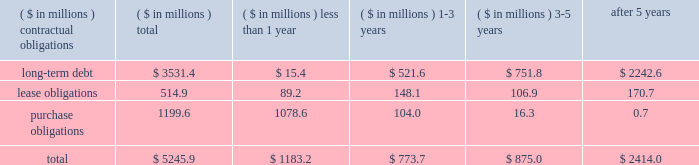The liabilities recognized as a result of consolidating these entities do not represent additional claims on the general assets of the company .
The creditors of these entities have claims only on the assets of the specific variable interest entities to which they have advanced credit .
Obligations and commitments as part of its ongoing operations , the company enters into arrangements that obligate the company to make future payments under contracts such as debt agreements , lease agreements , and unconditional purchase obligations ( i.e. , obligations to transfer funds in the future for fixed or minimum quantities of goods or services at fixed or minimum prices , such as 201ctake-or-pay 201d contracts ) .
The unconditional purchase obligation arrangements are entered into by the company in its normal course of business in order to ensure adequate levels of sourced product are available to the company .
Capital lease and debt obligations , which totaled $ 3.5 billion at may 25 , 2008 , are currently recognized as liabilities in the company 2019s consolidated balance sheet .
Operating lease obligations and unconditional purchase obligations , which totaled $ 1.7 billion at may 25 , 2008 , are not recognized as liabilities in the company 2019s consolidated balance sheet , in accordance with generally accepted accounting principles .
A summary of the company 2019s contractual obligations at the end of fiscal 2008 was as follows ( including obligations of discontinued operations ) : .
The purchase obligations noted in the table above do not reflect approximately $ 374 million of open purchase orders , some of which are not legally binding .
These purchase orders are settlable in the ordinary course of business in less than one year .
The company is also contractually obligated to pay interest on its long-term debt obligations .
The weighted average interest rate of the long-term debt obligations outstanding as of may 25 , 2008 was approximately 7.2% ( 7.2 % ) .
The company consolidates the assets and liabilities of certain entities from which it leases corporate aircraft .
These entities have been determined to be variable interest entities and the company has been determined to be the primary beneficiary of these entities .
The amounts reflected in contractual obligations of long-term debt , in the table above , include $ 54 million of liabilities of these variable interest entities to the creditors of such entities .
The long-term debt recognized as a result of consolidating these entities does not represent additional claims on the general assets of the company .
The creditors of these entities have claims only on the assets of the specific variable interest entities .
As of may 25 , 2008 , the company was obligated to make rental payments of $ 67 million to the variable interest entities , of which $ 7 million is due in less than one year , $ 13 million is due in one to three years , and $ 47 million is due in three to five years .
Such amounts are not reflected in the table , above .
As part of its ongoing operations , the company also enters into arrangements that obligate the company to make future cash payments only upon the occurrence of a future event ( e.g. , guarantee debt or lease payments of a third party should the third party be unable to perform ) .
In accordance with generally accepted accounting principles , the following commercial commitments are not recognized as liabilities in the company 2019s .
What percentage of total contractual obligations at the end of fiscal 2008 was due to long-term debt? 
Computations: (3531.4 / 5245.9)
Answer: 0.67317. 